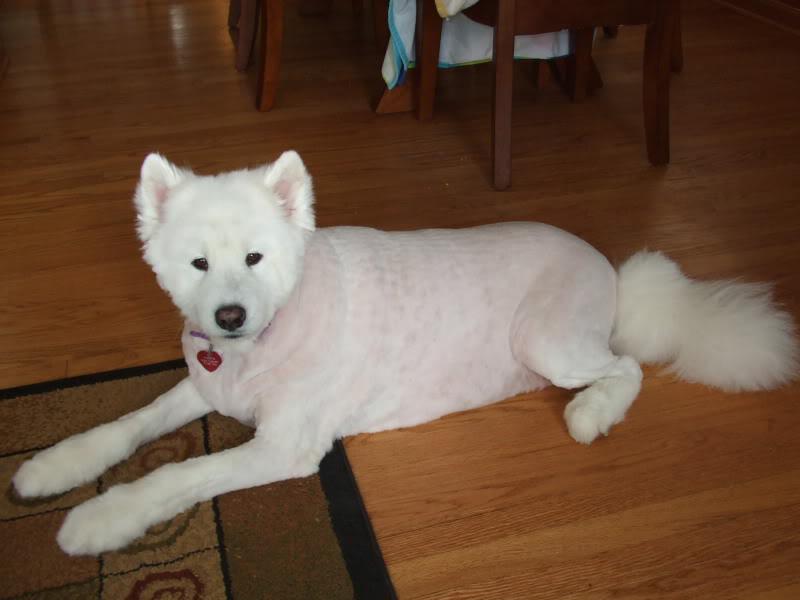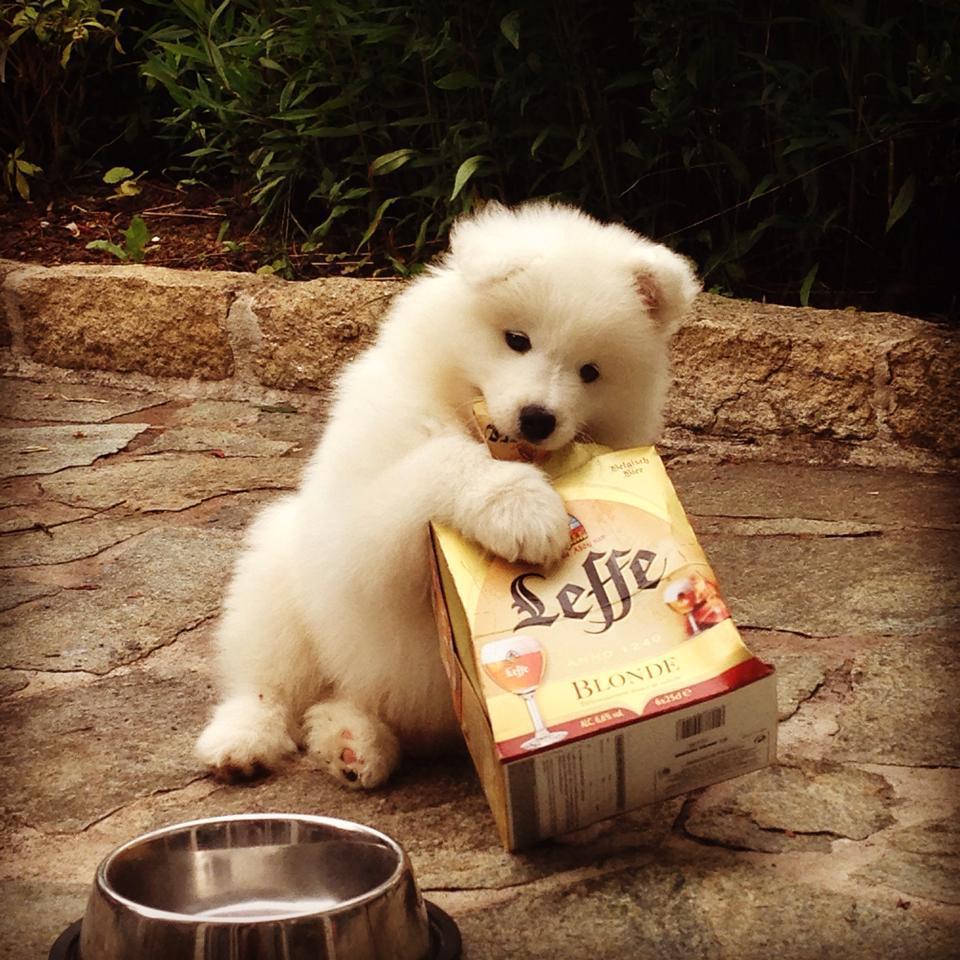The first image is the image on the left, the second image is the image on the right. Assess this claim about the two images: "a dog is indoors on a wooden floor". Correct or not? Answer yes or no. Yes. The first image is the image on the left, the second image is the image on the right. Evaluate the accuracy of this statement regarding the images: "A dog is on a wooden floor.". Is it true? Answer yes or no. Yes. 